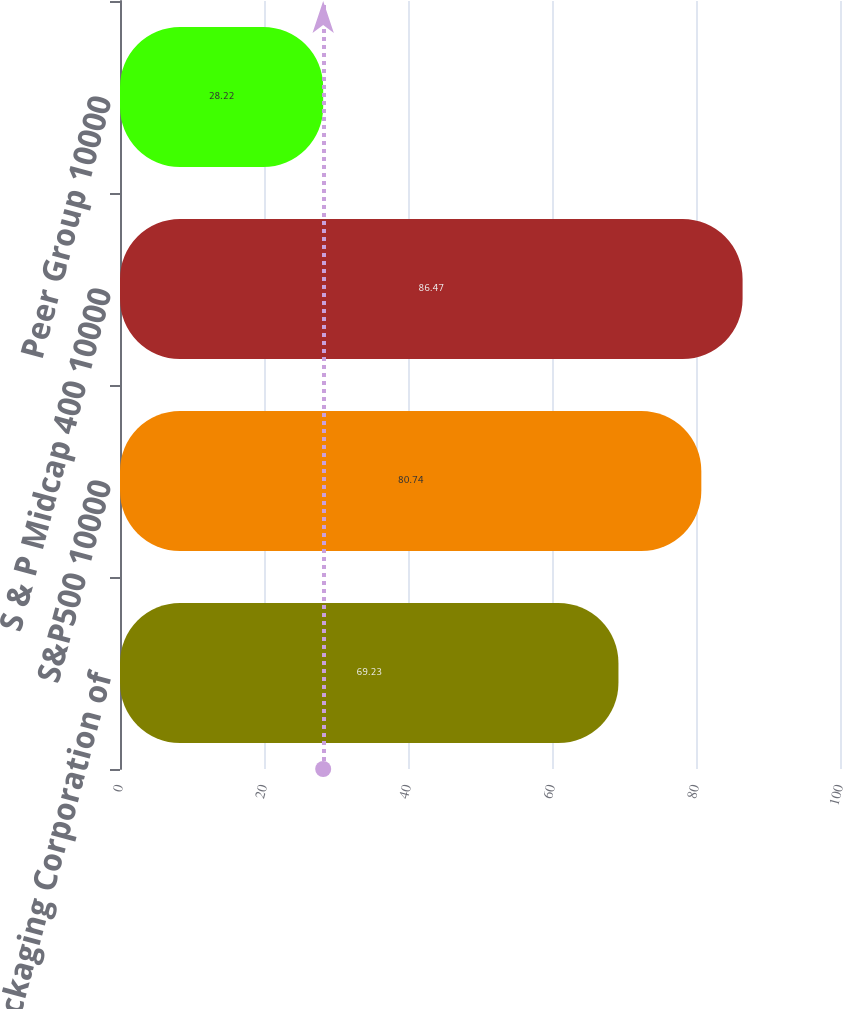Convert chart to OTSL. <chart><loc_0><loc_0><loc_500><loc_500><bar_chart><fcel>Packaging Corporation of<fcel>S&P500 10000<fcel>S & P Midcap 400 10000<fcel>Peer Group 10000<nl><fcel>69.23<fcel>80.74<fcel>86.47<fcel>28.22<nl></chart> 